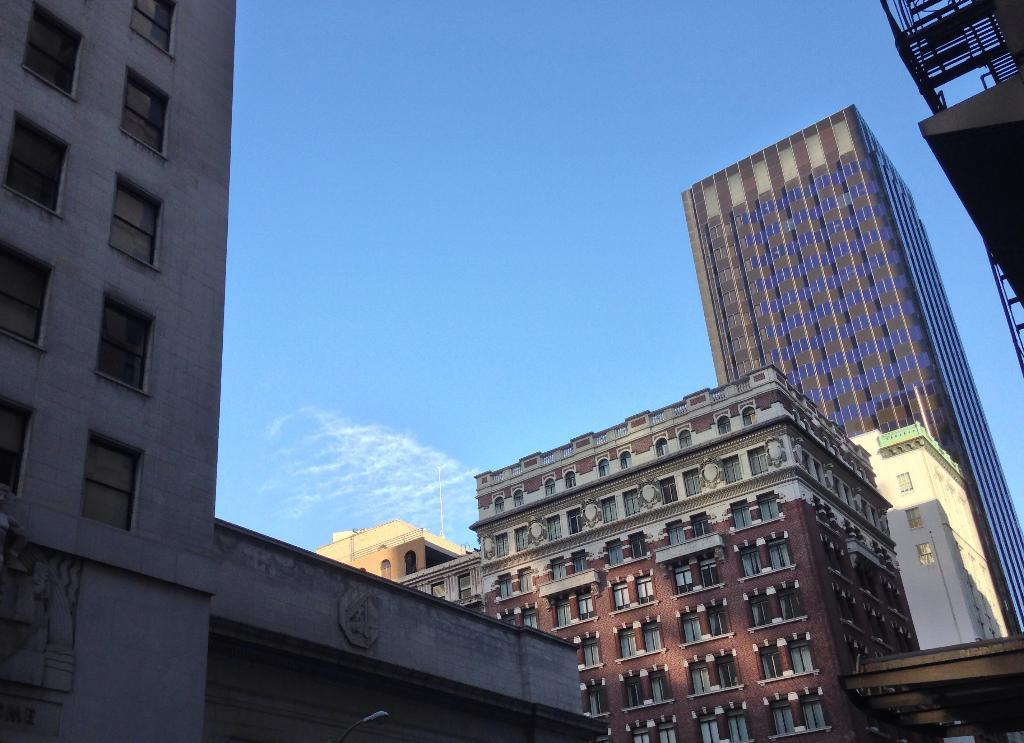What type of structures are present in the image? There are buildings in the image. Can you describe any specific features of the buildings? The buildings have windows. Where is the light located in the image? The light is at the bottom of the image. What is visible at the top of the image? The sky is visible at the top of the image. What type of punishment is being given to the aunt in the image? There is no aunt present in the image, nor is there any indication of punishment. 